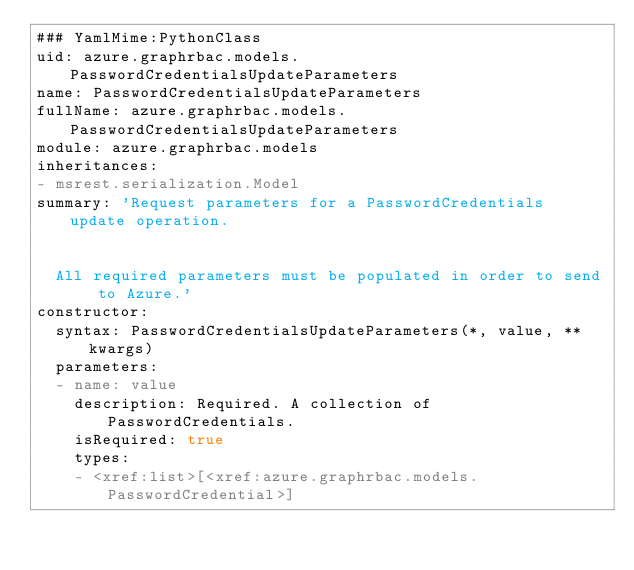Convert code to text. <code><loc_0><loc_0><loc_500><loc_500><_YAML_>### YamlMime:PythonClass
uid: azure.graphrbac.models.PasswordCredentialsUpdateParameters
name: PasswordCredentialsUpdateParameters
fullName: azure.graphrbac.models.PasswordCredentialsUpdateParameters
module: azure.graphrbac.models
inheritances:
- msrest.serialization.Model
summary: 'Request parameters for a PasswordCredentials update operation.


  All required parameters must be populated in order to send to Azure.'
constructor:
  syntax: PasswordCredentialsUpdateParameters(*, value, **kwargs)
  parameters:
  - name: value
    description: Required. A collection of PasswordCredentials.
    isRequired: true
    types:
    - <xref:list>[<xref:azure.graphrbac.models.PasswordCredential>]
</code> 